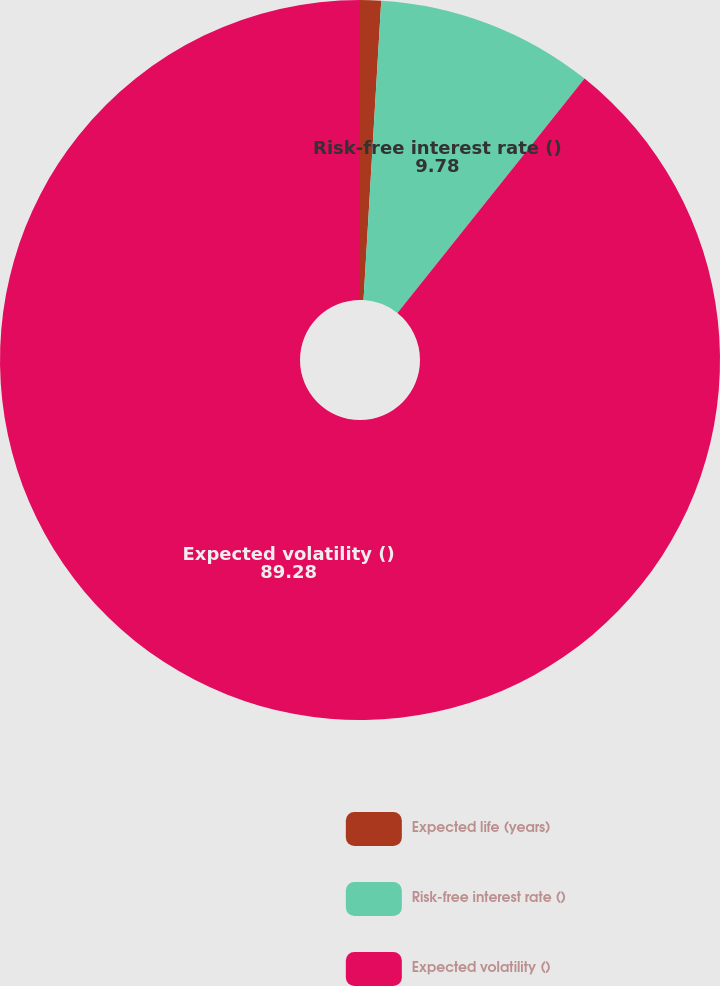<chart> <loc_0><loc_0><loc_500><loc_500><pie_chart><fcel>Expected life (years)<fcel>Risk-free interest rate ()<fcel>Expected volatility ()<nl><fcel>0.94%<fcel>9.78%<fcel>89.28%<nl></chart> 